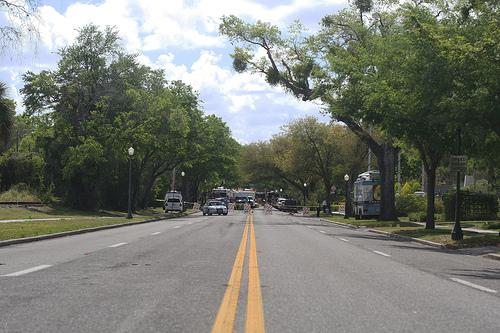Question: when was this photo taken?
Choices:
A. Morning.
B. Outside, during the daytime.
C. Noon.
D. Dusk.
Answer with the letter. Answer: B Question: what color are the road lines?
Choices:
A. Yellow.
B. Black.
C. Gray.
D. White.
Answer with the letter. Answer: A Question: what color is the road?
Choices:
A. Black.
B. White.
C. Gray.
D. Brown.
Answer with the letter. Answer: C 